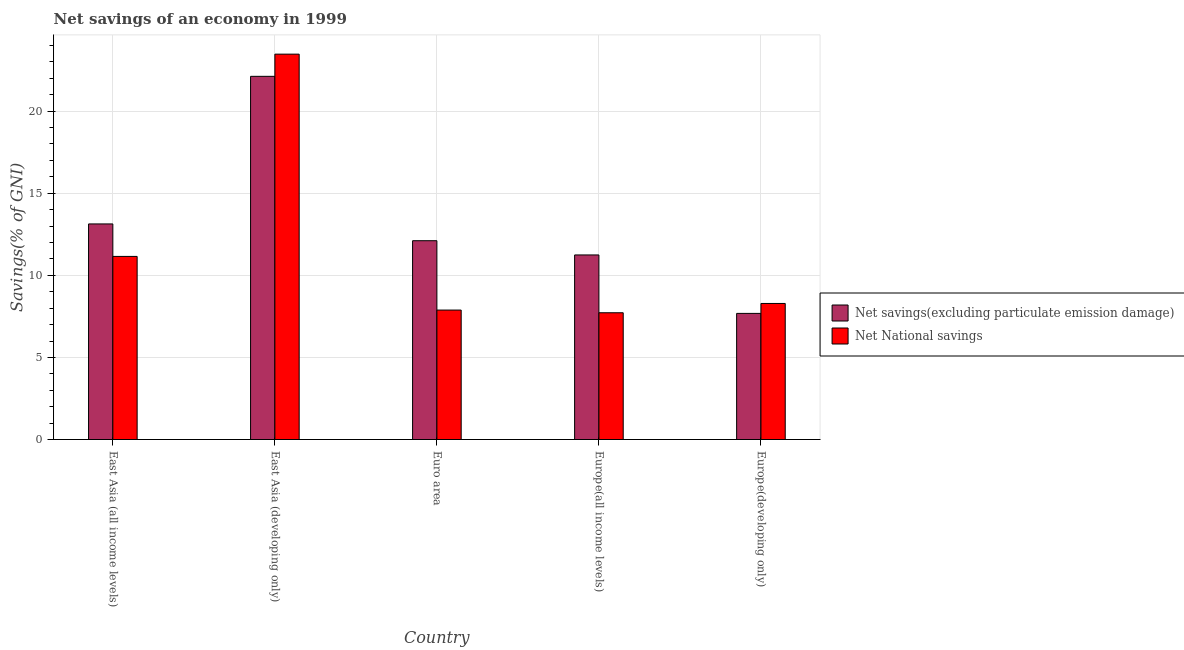How many groups of bars are there?
Offer a terse response. 5. Are the number of bars per tick equal to the number of legend labels?
Your answer should be very brief. Yes. Are the number of bars on each tick of the X-axis equal?
Keep it short and to the point. Yes. How many bars are there on the 4th tick from the left?
Make the answer very short. 2. How many bars are there on the 2nd tick from the right?
Keep it short and to the point. 2. What is the label of the 1st group of bars from the left?
Give a very brief answer. East Asia (all income levels). In how many cases, is the number of bars for a given country not equal to the number of legend labels?
Provide a succinct answer. 0. What is the net savings(excluding particulate emission damage) in Europe(developing only)?
Keep it short and to the point. 7.68. Across all countries, what is the maximum net savings(excluding particulate emission damage)?
Make the answer very short. 22.12. Across all countries, what is the minimum net savings(excluding particulate emission damage)?
Offer a very short reply. 7.68. In which country was the net savings(excluding particulate emission damage) maximum?
Your answer should be compact. East Asia (developing only). In which country was the net national savings minimum?
Provide a succinct answer. Europe(all income levels). What is the total net savings(excluding particulate emission damage) in the graph?
Provide a short and direct response. 66.28. What is the difference between the net national savings in East Asia (all income levels) and that in Europe(developing only)?
Keep it short and to the point. 2.87. What is the difference between the net savings(excluding particulate emission damage) in Euro area and the net national savings in Europe(developing only)?
Your answer should be compact. 3.82. What is the average net savings(excluding particulate emission damage) per country?
Your answer should be compact. 13.26. What is the difference between the net savings(excluding particulate emission damage) and net national savings in Europe(developing only)?
Keep it short and to the point. -0.6. In how many countries, is the net national savings greater than 2 %?
Ensure brevity in your answer.  5. What is the ratio of the net savings(excluding particulate emission damage) in East Asia (all income levels) to that in East Asia (developing only)?
Keep it short and to the point. 0.59. Is the net savings(excluding particulate emission damage) in East Asia (developing only) less than that in Europe(all income levels)?
Make the answer very short. No. Is the difference between the net savings(excluding particulate emission damage) in Euro area and Europe(all income levels) greater than the difference between the net national savings in Euro area and Europe(all income levels)?
Your response must be concise. Yes. What is the difference between the highest and the second highest net savings(excluding particulate emission damage)?
Provide a succinct answer. 8.99. What is the difference between the highest and the lowest net savings(excluding particulate emission damage)?
Provide a short and direct response. 14.44. Is the sum of the net national savings in East Asia (developing only) and Euro area greater than the maximum net savings(excluding particulate emission damage) across all countries?
Your response must be concise. Yes. What does the 1st bar from the left in East Asia (all income levels) represents?
Offer a very short reply. Net savings(excluding particulate emission damage). What does the 2nd bar from the right in Euro area represents?
Your answer should be compact. Net savings(excluding particulate emission damage). Are all the bars in the graph horizontal?
Keep it short and to the point. No. What is the difference between two consecutive major ticks on the Y-axis?
Your response must be concise. 5. Are the values on the major ticks of Y-axis written in scientific E-notation?
Make the answer very short. No. Does the graph contain any zero values?
Your answer should be compact. No. Does the graph contain grids?
Offer a very short reply. Yes. How are the legend labels stacked?
Offer a terse response. Vertical. What is the title of the graph?
Give a very brief answer. Net savings of an economy in 1999. Does "Central government" appear as one of the legend labels in the graph?
Give a very brief answer. No. What is the label or title of the Y-axis?
Your response must be concise. Savings(% of GNI). What is the Savings(% of GNI) in Net savings(excluding particulate emission damage) in East Asia (all income levels)?
Ensure brevity in your answer.  13.13. What is the Savings(% of GNI) in Net National savings in East Asia (all income levels)?
Offer a very short reply. 11.15. What is the Savings(% of GNI) in Net savings(excluding particulate emission damage) in East Asia (developing only)?
Offer a terse response. 22.12. What is the Savings(% of GNI) of Net National savings in East Asia (developing only)?
Make the answer very short. 23.47. What is the Savings(% of GNI) of Net savings(excluding particulate emission damage) in Euro area?
Keep it short and to the point. 12.11. What is the Savings(% of GNI) in Net National savings in Euro area?
Your response must be concise. 7.88. What is the Savings(% of GNI) of Net savings(excluding particulate emission damage) in Europe(all income levels)?
Provide a succinct answer. 11.24. What is the Savings(% of GNI) of Net National savings in Europe(all income levels)?
Make the answer very short. 7.72. What is the Savings(% of GNI) in Net savings(excluding particulate emission damage) in Europe(developing only)?
Provide a short and direct response. 7.68. What is the Savings(% of GNI) of Net National savings in Europe(developing only)?
Provide a succinct answer. 8.29. Across all countries, what is the maximum Savings(% of GNI) in Net savings(excluding particulate emission damage)?
Make the answer very short. 22.12. Across all countries, what is the maximum Savings(% of GNI) in Net National savings?
Your answer should be compact. 23.47. Across all countries, what is the minimum Savings(% of GNI) in Net savings(excluding particulate emission damage)?
Offer a very short reply. 7.68. Across all countries, what is the minimum Savings(% of GNI) in Net National savings?
Your answer should be very brief. 7.72. What is the total Savings(% of GNI) of Net savings(excluding particulate emission damage) in the graph?
Your answer should be very brief. 66.28. What is the total Savings(% of GNI) in Net National savings in the graph?
Offer a very short reply. 58.51. What is the difference between the Savings(% of GNI) of Net savings(excluding particulate emission damage) in East Asia (all income levels) and that in East Asia (developing only)?
Offer a terse response. -8.99. What is the difference between the Savings(% of GNI) in Net National savings in East Asia (all income levels) and that in East Asia (developing only)?
Ensure brevity in your answer.  -12.32. What is the difference between the Savings(% of GNI) in Net savings(excluding particulate emission damage) in East Asia (all income levels) and that in Euro area?
Provide a succinct answer. 1.02. What is the difference between the Savings(% of GNI) of Net National savings in East Asia (all income levels) and that in Euro area?
Give a very brief answer. 3.27. What is the difference between the Savings(% of GNI) in Net savings(excluding particulate emission damage) in East Asia (all income levels) and that in Europe(all income levels)?
Offer a terse response. 1.89. What is the difference between the Savings(% of GNI) in Net National savings in East Asia (all income levels) and that in Europe(all income levels)?
Provide a succinct answer. 3.43. What is the difference between the Savings(% of GNI) in Net savings(excluding particulate emission damage) in East Asia (all income levels) and that in Europe(developing only)?
Provide a short and direct response. 5.45. What is the difference between the Savings(% of GNI) of Net National savings in East Asia (all income levels) and that in Europe(developing only)?
Give a very brief answer. 2.87. What is the difference between the Savings(% of GNI) in Net savings(excluding particulate emission damage) in East Asia (developing only) and that in Euro area?
Provide a succinct answer. 10.01. What is the difference between the Savings(% of GNI) of Net National savings in East Asia (developing only) and that in Euro area?
Provide a succinct answer. 15.59. What is the difference between the Savings(% of GNI) in Net savings(excluding particulate emission damage) in East Asia (developing only) and that in Europe(all income levels)?
Make the answer very short. 10.88. What is the difference between the Savings(% of GNI) in Net National savings in East Asia (developing only) and that in Europe(all income levels)?
Ensure brevity in your answer.  15.75. What is the difference between the Savings(% of GNI) in Net savings(excluding particulate emission damage) in East Asia (developing only) and that in Europe(developing only)?
Make the answer very short. 14.44. What is the difference between the Savings(% of GNI) in Net National savings in East Asia (developing only) and that in Europe(developing only)?
Provide a short and direct response. 15.18. What is the difference between the Savings(% of GNI) in Net savings(excluding particulate emission damage) in Euro area and that in Europe(all income levels)?
Offer a very short reply. 0.87. What is the difference between the Savings(% of GNI) in Net National savings in Euro area and that in Europe(all income levels)?
Ensure brevity in your answer.  0.16. What is the difference between the Savings(% of GNI) of Net savings(excluding particulate emission damage) in Euro area and that in Europe(developing only)?
Your answer should be compact. 4.43. What is the difference between the Savings(% of GNI) in Net National savings in Euro area and that in Europe(developing only)?
Your answer should be compact. -0.4. What is the difference between the Savings(% of GNI) in Net savings(excluding particulate emission damage) in Europe(all income levels) and that in Europe(developing only)?
Offer a very short reply. 3.56. What is the difference between the Savings(% of GNI) of Net National savings in Europe(all income levels) and that in Europe(developing only)?
Make the answer very short. -0.57. What is the difference between the Savings(% of GNI) of Net savings(excluding particulate emission damage) in East Asia (all income levels) and the Savings(% of GNI) of Net National savings in East Asia (developing only)?
Ensure brevity in your answer.  -10.34. What is the difference between the Savings(% of GNI) in Net savings(excluding particulate emission damage) in East Asia (all income levels) and the Savings(% of GNI) in Net National savings in Euro area?
Your answer should be compact. 5.25. What is the difference between the Savings(% of GNI) of Net savings(excluding particulate emission damage) in East Asia (all income levels) and the Savings(% of GNI) of Net National savings in Europe(all income levels)?
Your response must be concise. 5.41. What is the difference between the Savings(% of GNI) of Net savings(excluding particulate emission damage) in East Asia (all income levels) and the Savings(% of GNI) of Net National savings in Europe(developing only)?
Offer a terse response. 4.84. What is the difference between the Savings(% of GNI) in Net savings(excluding particulate emission damage) in East Asia (developing only) and the Savings(% of GNI) in Net National savings in Euro area?
Offer a very short reply. 14.24. What is the difference between the Savings(% of GNI) in Net savings(excluding particulate emission damage) in East Asia (developing only) and the Savings(% of GNI) in Net National savings in Europe(all income levels)?
Make the answer very short. 14.4. What is the difference between the Savings(% of GNI) of Net savings(excluding particulate emission damage) in East Asia (developing only) and the Savings(% of GNI) of Net National savings in Europe(developing only)?
Provide a succinct answer. 13.83. What is the difference between the Savings(% of GNI) of Net savings(excluding particulate emission damage) in Euro area and the Savings(% of GNI) of Net National savings in Europe(all income levels)?
Offer a very short reply. 4.39. What is the difference between the Savings(% of GNI) of Net savings(excluding particulate emission damage) in Euro area and the Savings(% of GNI) of Net National savings in Europe(developing only)?
Offer a very short reply. 3.82. What is the difference between the Savings(% of GNI) in Net savings(excluding particulate emission damage) in Europe(all income levels) and the Savings(% of GNI) in Net National savings in Europe(developing only)?
Your answer should be compact. 2.96. What is the average Savings(% of GNI) in Net savings(excluding particulate emission damage) per country?
Your response must be concise. 13.26. What is the average Savings(% of GNI) of Net National savings per country?
Keep it short and to the point. 11.7. What is the difference between the Savings(% of GNI) in Net savings(excluding particulate emission damage) and Savings(% of GNI) in Net National savings in East Asia (all income levels)?
Give a very brief answer. 1.98. What is the difference between the Savings(% of GNI) in Net savings(excluding particulate emission damage) and Savings(% of GNI) in Net National savings in East Asia (developing only)?
Your answer should be compact. -1.35. What is the difference between the Savings(% of GNI) of Net savings(excluding particulate emission damage) and Savings(% of GNI) of Net National savings in Euro area?
Offer a very short reply. 4.22. What is the difference between the Savings(% of GNI) in Net savings(excluding particulate emission damage) and Savings(% of GNI) in Net National savings in Europe(all income levels)?
Your response must be concise. 3.52. What is the difference between the Savings(% of GNI) of Net savings(excluding particulate emission damage) and Savings(% of GNI) of Net National savings in Europe(developing only)?
Ensure brevity in your answer.  -0.6. What is the ratio of the Savings(% of GNI) of Net savings(excluding particulate emission damage) in East Asia (all income levels) to that in East Asia (developing only)?
Offer a terse response. 0.59. What is the ratio of the Savings(% of GNI) in Net National savings in East Asia (all income levels) to that in East Asia (developing only)?
Your answer should be compact. 0.48. What is the ratio of the Savings(% of GNI) in Net savings(excluding particulate emission damage) in East Asia (all income levels) to that in Euro area?
Keep it short and to the point. 1.08. What is the ratio of the Savings(% of GNI) in Net National savings in East Asia (all income levels) to that in Euro area?
Offer a very short reply. 1.41. What is the ratio of the Savings(% of GNI) of Net savings(excluding particulate emission damage) in East Asia (all income levels) to that in Europe(all income levels)?
Give a very brief answer. 1.17. What is the ratio of the Savings(% of GNI) of Net National savings in East Asia (all income levels) to that in Europe(all income levels)?
Offer a terse response. 1.44. What is the ratio of the Savings(% of GNI) of Net savings(excluding particulate emission damage) in East Asia (all income levels) to that in Europe(developing only)?
Offer a terse response. 1.71. What is the ratio of the Savings(% of GNI) in Net National savings in East Asia (all income levels) to that in Europe(developing only)?
Keep it short and to the point. 1.35. What is the ratio of the Savings(% of GNI) in Net savings(excluding particulate emission damage) in East Asia (developing only) to that in Euro area?
Offer a very short reply. 1.83. What is the ratio of the Savings(% of GNI) in Net National savings in East Asia (developing only) to that in Euro area?
Provide a short and direct response. 2.98. What is the ratio of the Savings(% of GNI) in Net savings(excluding particulate emission damage) in East Asia (developing only) to that in Europe(all income levels)?
Your response must be concise. 1.97. What is the ratio of the Savings(% of GNI) of Net National savings in East Asia (developing only) to that in Europe(all income levels)?
Your response must be concise. 3.04. What is the ratio of the Savings(% of GNI) in Net savings(excluding particulate emission damage) in East Asia (developing only) to that in Europe(developing only)?
Ensure brevity in your answer.  2.88. What is the ratio of the Savings(% of GNI) in Net National savings in East Asia (developing only) to that in Europe(developing only)?
Your answer should be compact. 2.83. What is the ratio of the Savings(% of GNI) in Net savings(excluding particulate emission damage) in Euro area to that in Europe(all income levels)?
Ensure brevity in your answer.  1.08. What is the ratio of the Savings(% of GNI) of Net National savings in Euro area to that in Europe(all income levels)?
Your answer should be very brief. 1.02. What is the ratio of the Savings(% of GNI) of Net savings(excluding particulate emission damage) in Euro area to that in Europe(developing only)?
Offer a terse response. 1.58. What is the ratio of the Savings(% of GNI) of Net National savings in Euro area to that in Europe(developing only)?
Offer a very short reply. 0.95. What is the ratio of the Savings(% of GNI) of Net savings(excluding particulate emission damage) in Europe(all income levels) to that in Europe(developing only)?
Give a very brief answer. 1.46. What is the ratio of the Savings(% of GNI) of Net National savings in Europe(all income levels) to that in Europe(developing only)?
Ensure brevity in your answer.  0.93. What is the difference between the highest and the second highest Savings(% of GNI) of Net savings(excluding particulate emission damage)?
Your answer should be very brief. 8.99. What is the difference between the highest and the second highest Savings(% of GNI) in Net National savings?
Your answer should be very brief. 12.32. What is the difference between the highest and the lowest Savings(% of GNI) of Net savings(excluding particulate emission damage)?
Give a very brief answer. 14.44. What is the difference between the highest and the lowest Savings(% of GNI) of Net National savings?
Offer a very short reply. 15.75. 